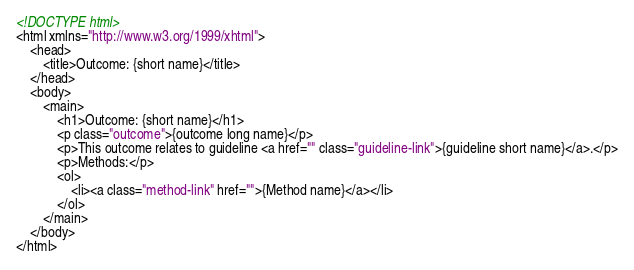<code> <loc_0><loc_0><loc_500><loc_500><_HTML_><!DOCTYPE html>
<html xmlns="http://www.w3.org/1999/xhtml">
	<head>
		<title>Outcome: {short name}</title>
	</head>
	<body>
		<main>
			<h1>Outcome: {short name}</h1>
			<p class="outcome">{outcome long name}</p>
			<p>This outcome relates to guideline <a href="" class="guideline-link">{guideline short name}</a>.</p>
			<p>Methods:</p>
			<ol>
				<li><a class="method-link" href="">{Method name}</a></li>
			</ol>
		</main>
	</body>
</html></code> 